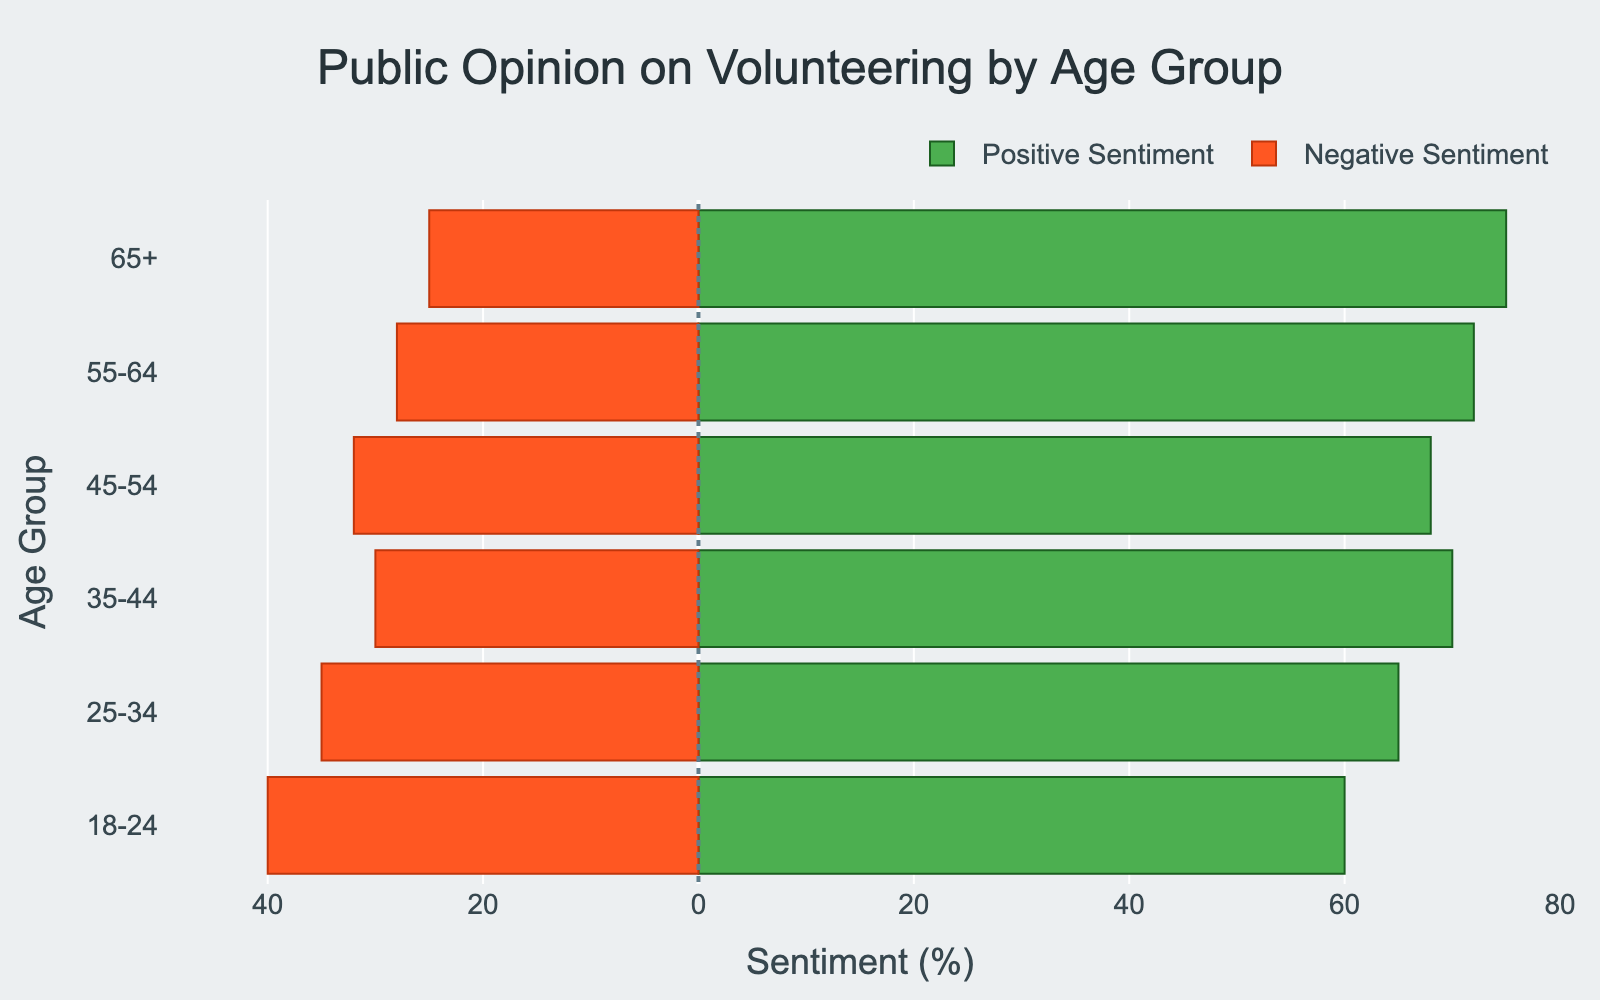What age group has the highest positive sentiment towards volunteering? The age group with the highest positive sentiment is shown by the longest green bar. The longest green bar corresponds to the 65+ age group.
Answer: 65+ What is the difference between positive and negative sentiment for the 35-44 age group? The positive sentiment for the 35-44 age group is 70%, and the negative sentiment is 30%. The difference is calculated as 70 - 30.
Answer: 40% Among the 18-24 and 55-64 age groups, which one has a higher negative sentiment? Compare the length of the red bars for the 18-24 and 55-64 age groups. The red bar is longer for the 18-24 age group.
Answer: 18-24 What is the combined sentiment (positive and negative) for the 25-34 age group? The positive sentiment for the 25-34 age group is 65%, and the negative sentiment is 35%. The combined sentiment is calculated as 65 + 35.
Answer: 100% Which age group shows the smallest difference between positive and negative sentiment? To find the smallest difference, subtract negative sentiment from positive sentiment for each group and compare. The 45-54 age group has the smallest difference (68 - 32).
Answer: 45-54 How many age groups have a positive sentiment greater than 70%? Identify the age groups where the green bar indicating positive sentiment is longer than 70%. The 55-64 and 65+ age groups have positive sentiment greater than 70%.
Answer: 2 Which age group's negative sentiment is closest to 30%? Compare the red bars to see which one is closest to the -30 mark on the x-axis. The 35-44 age group's negative sentiment is closest to 30%.
Answer: 35-44 What is the range of positive sentiment values across all age groups? The highest positive sentiment is 75% (65+ age group), and the lowest is 60% (18-24 age group). The range is calculated as 75 - 60.
Answer: 15% Is the negative sentiment for the 55-64 age group less than or greater than 30%? Check the length of the red bar for the 55-64 age group; it shows -28%. Since -28 is less than -30, the negative sentiment is less.
Answer: Less than 30% 